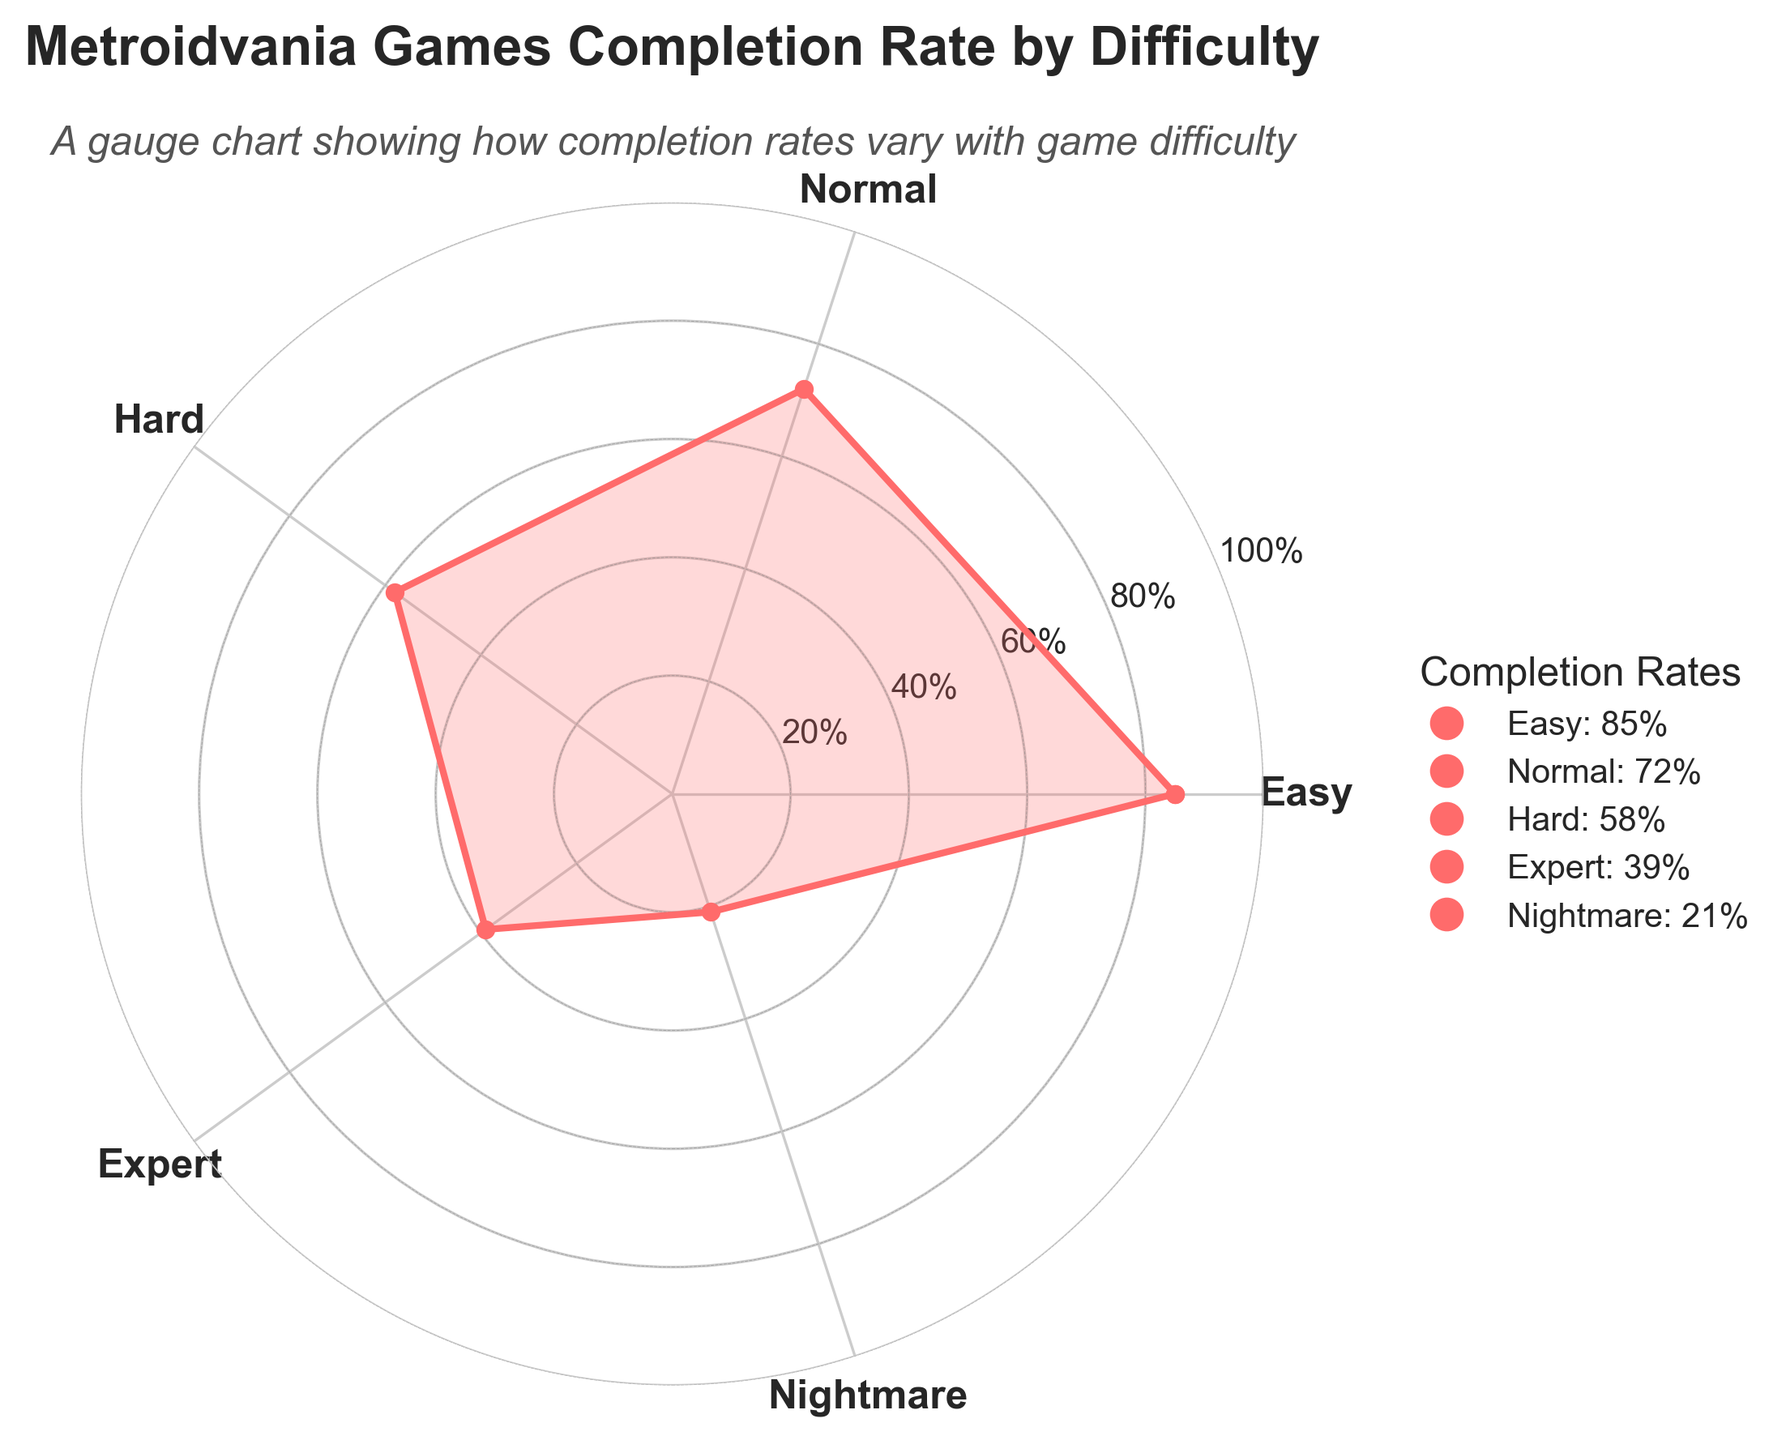What are the axis labels in the plot? The axis labels at the radial positions represent the difficulty levels: Easy, Normal, Hard, Expert, Nightmare. These labels help in identifying the completion rate corresponding to each difficulty level.
Answer: Easy, Normal, Hard, Expert, Nightmare What is the title of the plot? The title of the plot is located at the top and provides a summary of what the chart is about.
Answer: Metroidvania Games Completion Rate by Difficulty Which difficulty level has the lowest completion rate? By looking at the data points on the plot, the difficulty level with the smallest distance from the center of the polar plot indicates the lowest completion rate.
Answer: Nightmare What is the difference in completion rate between Easy and Hard difficulty levels? To find the difference, subtract the completion rate of Hard (58%) from the completion rate of Easy (85%).
Answer: 27% Which difficulty has a higher completion rate: Normal or Expert? Compare the radial positions of Normal and Expert; the one farther from the center has the higher completion rate.
Answer: Normal How does the completion rate change from Easy to Nightmare? To answer this, observe how the data points change from Easy to Nightmare. The completion rate decreases as the difficulty level increases, starting from 85% at Easy to 21% at Nightmare.
Answer: Decreases What's the average completion rate across all the difficulty levels? First, sum up the completion rates of all difficulty levels: Easy (85%) + Normal (72%) + Hard (58%) + Expert (39%) + Nightmare (21%), which equals 275%. Then, divide by the number of difficulty levels (5).
Answer: 55% How many completion rates exceed 50%? By counting the data points with completion rates above 50%, we find that Easy (85%), Normal (72%), and Hard (58%) exceed 50%.
Answer: 3 Describe the type of plot used and its uniqueness in representing the data? The plot is a gauge chart using polar coordinates. It's unique in its ability to show the completion rates in a circular, radial manner, which makes it visually intuitive to compare the differences among difficulty levels.
Answer: Gauge Chart, Polar plot Which difficulty level is closest in completion rate to Normal? Comparing the marked points, it's Hard (58%) that is closest to Normal (72%). The difference of 14 between these two is the smallest compared to the other difficulties.
Answer: Hard 